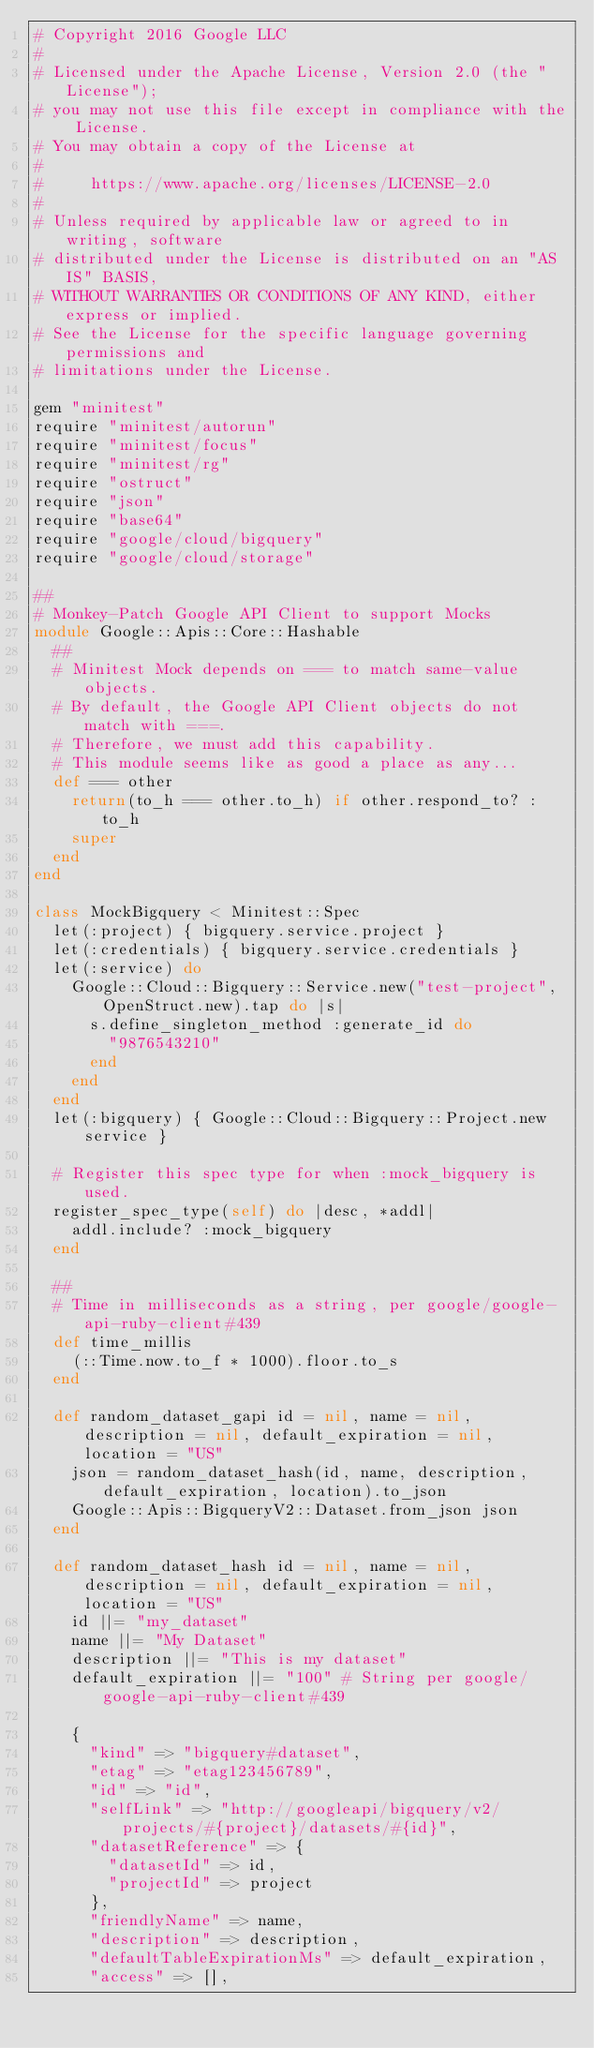<code> <loc_0><loc_0><loc_500><loc_500><_Ruby_># Copyright 2016 Google LLC
#
# Licensed under the Apache License, Version 2.0 (the "License");
# you may not use this file except in compliance with the License.
# You may obtain a copy of the License at
#
#     https://www.apache.org/licenses/LICENSE-2.0
#
# Unless required by applicable law or agreed to in writing, software
# distributed under the License is distributed on an "AS IS" BASIS,
# WITHOUT WARRANTIES OR CONDITIONS OF ANY KIND, either express or implied.
# See the License for the specific language governing permissions and
# limitations under the License.

gem "minitest"
require "minitest/autorun"
require "minitest/focus"
require "minitest/rg"
require "ostruct"
require "json"
require "base64"
require "google/cloud/bigquery"
require "google/cloud/storage"

##
# Monkey-Patch Google API Client to support Mocks
module Google::Apis::Core::Hashable
  ##
  # Minitest Mock depends on === to match same-value objects.
  # By default, the Google API Client objects do not match with ===.
  # Therefore, we must add this capability.
  # This module seems like as good a place as any...
  def === other
    return(to_h === other.to_h) if other.respond_to? :to_h
    super
  end
end

class MockBigquery < Minitest::Spec
  let(:project) { bigquery.service.project }
  let(:credentials) { bigquery.service.credentials }
  let(:service) do
    Google::Cloud::Bigquery::Service.new("test-project", OpenStruct.new).tap do |s|
      s.define_singleton_method :generate_id do
        "9876543210"
      end
    end
  end
  let(:bigquery) { Google::Cloud::Bigquery::Project.new service }

  # Register this spec type for when :mock_bigquery is used.
  register_spec_type(self) do |desc, *addl|
    addl.include? :mock_bigquery
  end

  ##
  # Time in milliseconds as a string, per google/google-api-ruby-client#439
  def time_millis
    (::Time.now.to_f * 1000).floor.to_s
  end

  def random_dataset_gapi id = nil, name = nil, description = nil, default_expiration = nil, location = "US"
    json = random_dataset_hash(id, name, description, default_expiration, location).to_json
    Google::Apis::BigqueryV2::Dataset.from_json json
  end

  def random_dataset_hash id = nil, name = nil, description = nil, default_expiration = nil, location = "US"
    id ||= "my_dataset"
    name ||= "My Dataset"
    description ||= "This is my dataset"
    default_expiration ||= "100" # String per google/google-api-ruby-client#439

    {
      "kind" => "bigquery#dataset",
      "etag" => "etag123456789",
      "id" => "id",
      "selfLink" => "http://googleapi/bigquery/v2/projects/#{project}/datasets/#{id}",
      "datasetReference" => {
        "datasetId" => id,
        "projectId" => project
      },
      "friendlyName" => name,
      "description" => description,
      "defaultTableExpirationMs" => default_expiration,
      "access" => [],</code> 